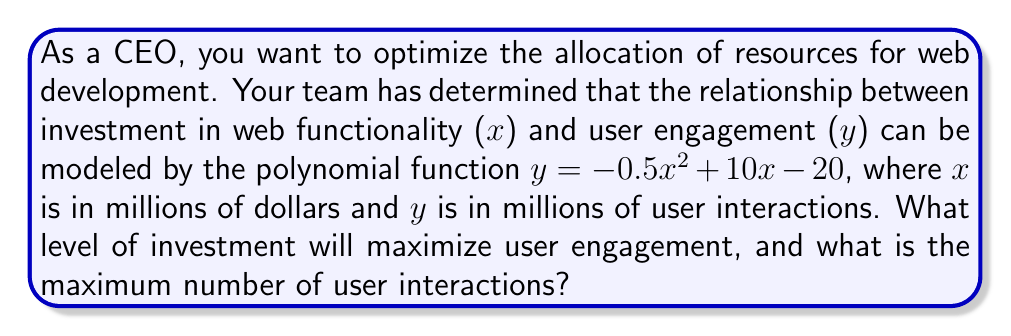Could you help me with this problem? To find the optimal investment and maximum user engagement, we need to follow these steps:

1. The given polynomial function is quadratic: $y = -0.5x^2 + 10x - 20$

2. To find the maximum point, we need to find the vertex of the parabola. For a quadratic function in the form $y = ax^2 + bx + c$, the x-coordinate of the vertex is given by $x = -\frac{b}{2a}$

3. In our case, $a = -0.5$, $b = 10$, and $c = -20$

4. Calculating the x-coordinate of the vertex:
   $x = -\frac{10}{2(-0.5)} = -\frac{10}{-1} = 10$

5. This means the optimal investment is $10 million

6. To find the maximum number of user interactions, we substitute x = 10 into the original function:
   $y = -0.5(10)^2 + 10(10) - 20$
   $y = -0.5(100) + 100 - 20$
   $y = -50 + 100 - 20$
   $y = 30$

Therefore, the maximum number of user interactions is 30 million.
Answer: $10 million investment; 30 million user interactions 